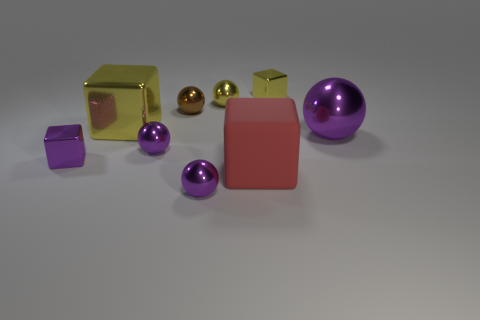What material is the big cube that is behind the large sphere?
Provide a succinct answer. Metal. What is the material of the large red object?
Keep it short and to the point. Rubber. What is the tiny yellow thing to the left of the yellow metal block that is right of the big metal thing behind the large purple metallic object made of?
Your response must be concise. Metal. Are there any other things that have the same material as the tiny yellow ball?
Your response must be concise. Yes. Is the size of the rubber object the same as the ball that is in front of the red cube?
Your answer should be very brief. No. What number of things are either metal cubes in front of the yellow shiny sphere or tiny objects behind the large matte cube?
Your response must be concise. 6. What color is the metallic ball that is to the right of the large rubber cube?
Your answer should be compact. Purple. There is a brown metal sphere behind the large matte thing; is there a tiny shiny object that is in front of it?
Keep it short and to the point. Yes. Is the number of tiny yellow metal spheres less than the number of tiny gray metallic objects?
Offer a very short reply. No. What material is the big thing in front of the ball that is on the right side of the matte block made of?
Provide a short and direct response. Rubber. 